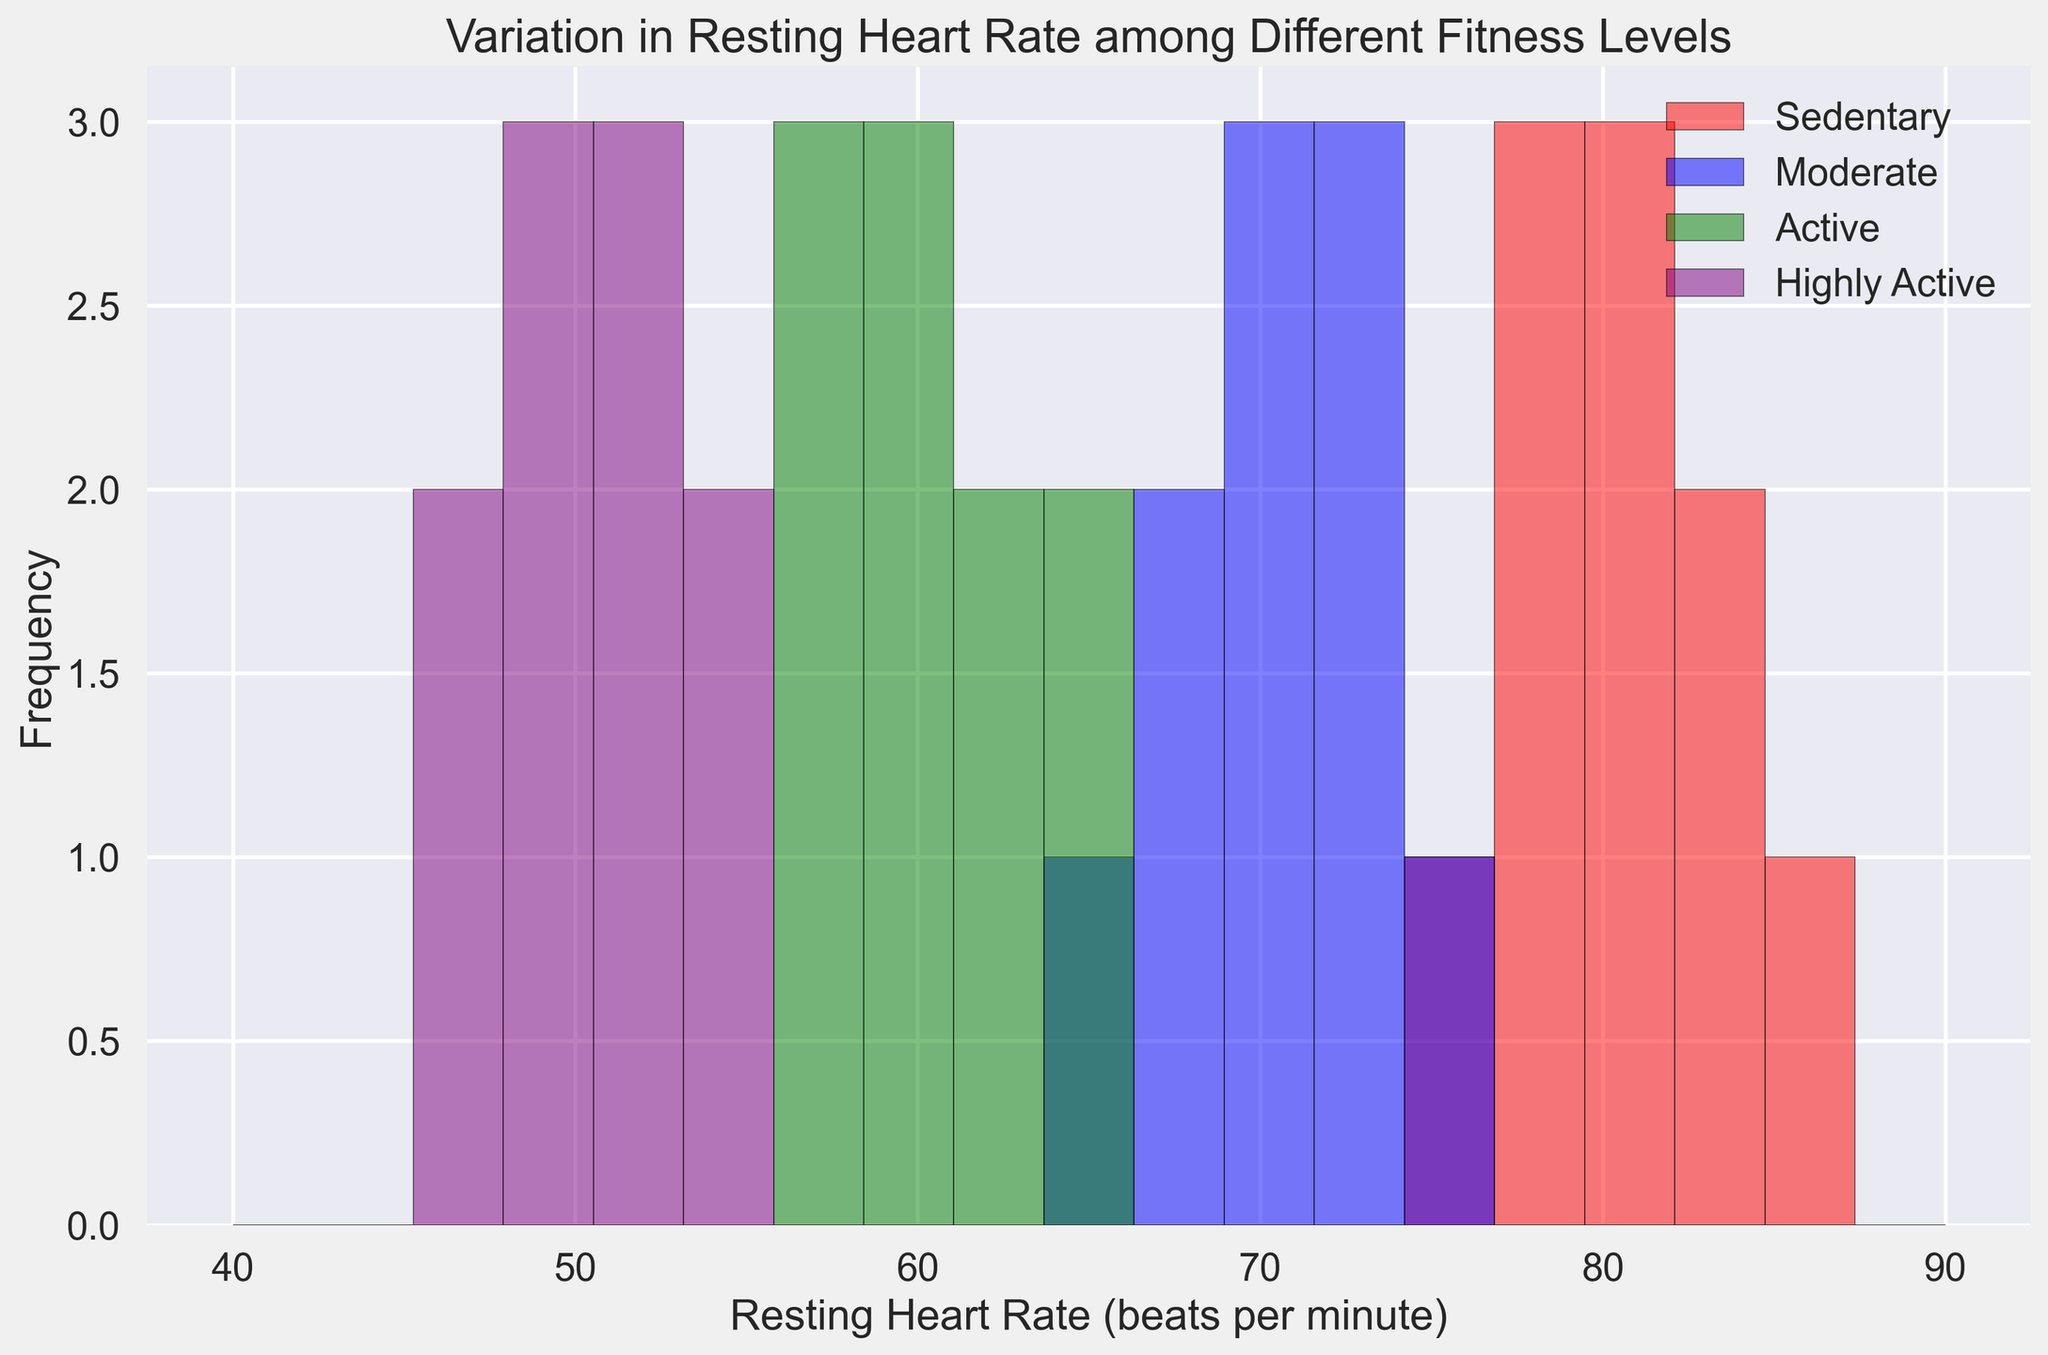What is the average resting heart rate for the "Sedentary" group? Sum all resting heart rates for the Sedentary group: (78 + 82 + 80 + 76 + 85 + 79 + 77 + 83 + 81 + 84) = 805. Divide by the number of data points (10). The average is 805 / 10 = 80.5
Answer: 80.5 Which fitness level has the lowest resting heart rate range? The Highly Active group spans resting heart rates from approximately 46 to 55, which is the narrowest range among the groups.
Answer: Highly Active Which fitness level shows the highest frequency of resting heart rates around 80 bpm? The Sedentary group has the highest bar (frequency) around 80 bpm as shown by the red bar height around that value.
Answer: Sedentary What's the difference in the average resting heart rate between the "Active" and "Moderate" fitness levels? First, find the averages for each group. For Active: (60 + 62 + 58 + 63 + 61 + 57 + 64 + 65 + 59 + 56) / 10 = 60.5. For Moderate: (72 + 70 + 68 + 74 + 71 + 69 + 67 + 73 + 75 + 66) / 10 = 70. The difference is 70 - 60.5 = 9.5
Answer: 9.5 Which fitness level group has resting heart rates that never exceed 75 bpm? Observing the histogram, the Highly Active group (purple bars) never goes beyond 55 bpm.
Answer: Highly Active Compare the resting heart rate distributions of "Sedentary" and "Moderate" groups. Which one has a wider range? Sedentary group has resting heart rates ranging from 76 to 85, while Moderate ranges from 66 to 75. Thus, Sedentary has a wider range.
Answer: Sedentary How many fitness levels have their resting heart rate frequencies peaking below 70 bpm? Both the Active and Highly Active groups show peaks (highest bars) below 70 bpm based on the histogram.
Answer: Two Which group has the most concentrated resting heart rate distribution, and what is the range? The Highly Active group has the most concentrated distribution, ranging from approximately 46 to 55 bpm.
Answer: Highly Active, 46-55 bpm 